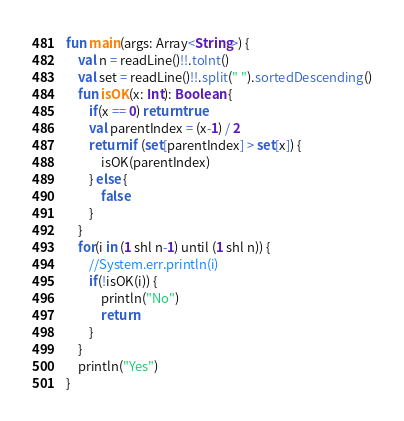Convert code to text. <code><loc_0><loc_0><loc_500><loc_500><_Kotlin_>fun main(args: Array<String>) {
    val n = readLine()!!.toInt()
    val set = readLine()!!.split(" ").sortedDescending()
    fun isOK(x: Int): Boolean {
        if(x == 0) return true
        val parentIndex = (x-1) / 2
        return if (set[parentIndex] > set[x]) {
            isOK(parentIndex)
        } else {
            false
        }
    }
    for(i in (1 shl n-1) until (1 shl n)) {
        //System.err.println(i)
        if(!isOK(i)) {
            println("No")
            return
        }
    }
    println("Yes")
}</code> 